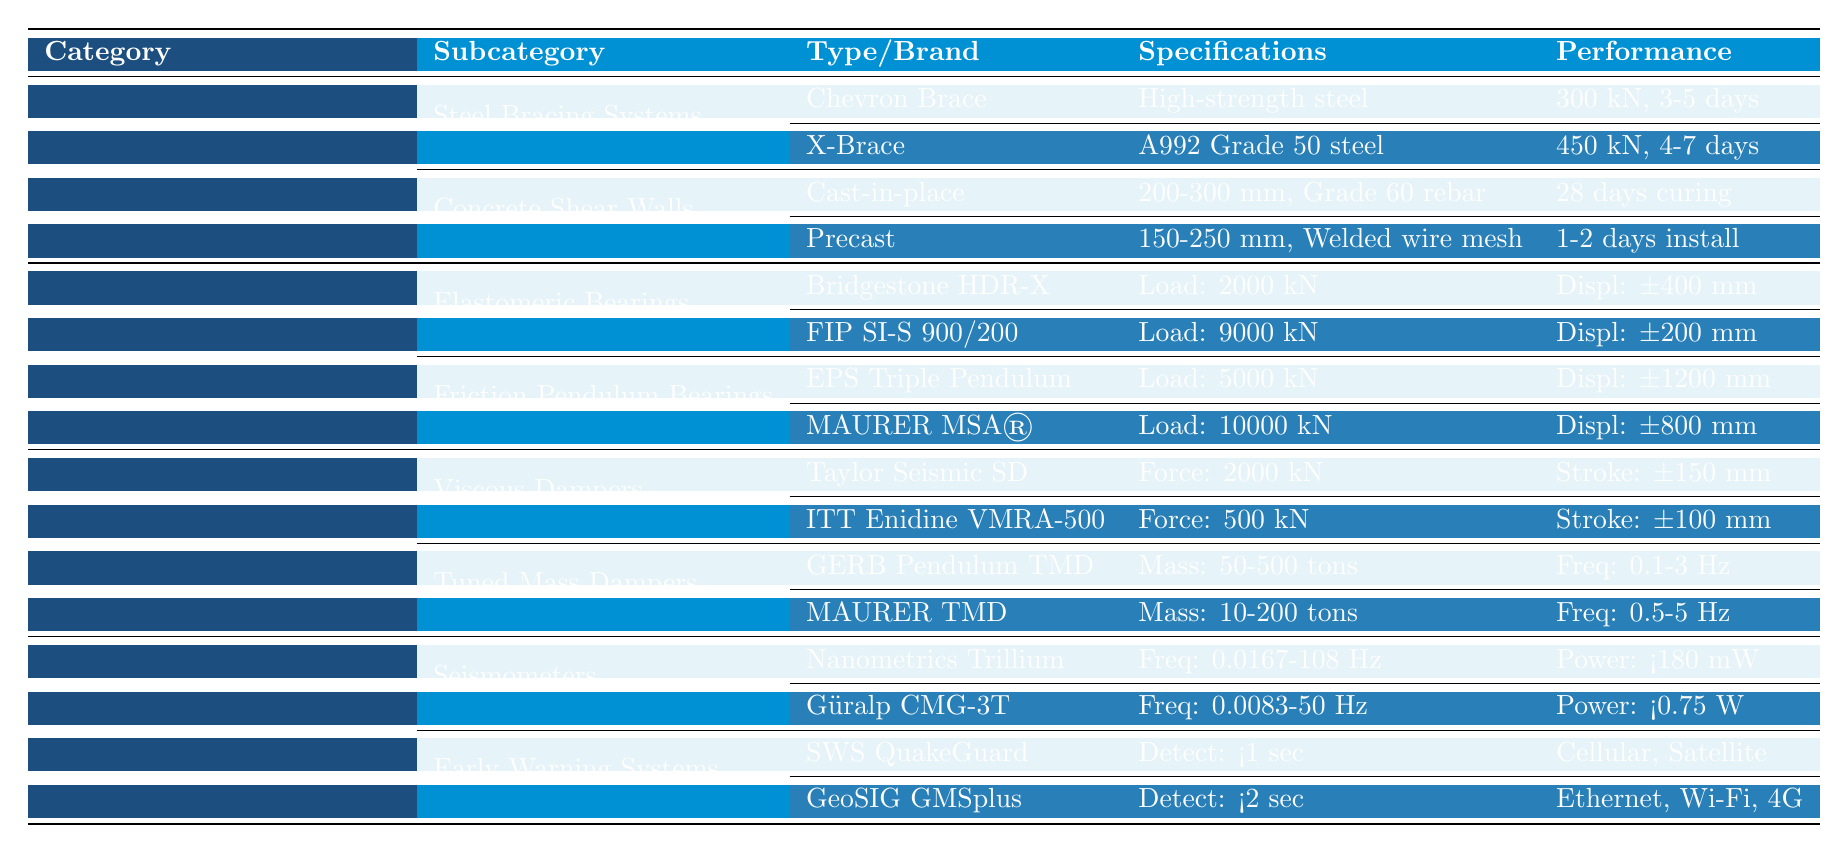What is the load capacity of the X-Brace? The table shows the specifications for the X-Brace under Steel Bracing Systems, indicating a load capacity of 450 kN.
Answer: 450 kN How many installation days are required for the Chevron Brace? The installation time for the Chevron Brace, listed in the Steel Bracing Systems, is between 3 to 5 days.
Answer: 3-5 days Which brand and model of elastomeric bearings has the highest load capacity? Comparing the load capacities listed under Elastomeric Bearings, the FIP SI-S 900/200 has the highest load capacity of 9000 kN, compared to Bridgestone HDR-X with 2000 kN.
Answer: FIP SI-S 900/200 Does the MAURER MSA® Friction Pendulum Bearing have a greater load capacity than the EPS Triple Pendulum? According to the table, the MAURER MSA® has a load capacity of 10000 kN, while the EPS Triple Pendulum has a load capacity of 5000 kN. Therefore, MAURER MSA® does have a greater load capacity.
Answer: Yes What is the frequency range of the GERB Pendulum TMD? The frequency range for the GERB Pendulum TMD, indicated in the Tuned Mass Dampers section, is from 0.1 to 3 Hz.
Answer: 0.1-3 Hz How does the stroke of the Taylor Seismic Damper compare to the stroke of the ITT Enidine VMRA-500? The stroke of the Taylor Seismic Damper is ±150 mm, which is greater than the stroke of the ITT Enidine VMRA-500, which is ±100 mm.
Answer: Greater What is the average detection time for the Early Warning Systems listed? The detection times for SWS QuakeGuard and GeoSIG GMSplus are <1 second and <2 seconds, respectively. Calculating the average: (1 + 2)/2 = 1.5 seconds.
Answer: 1.5 seconds Which has a shorter curing time, Cast-in-place or Precast Concrete Shear Walls? The Cast-in-place wall requires a curing time of 28 days, while the Precast wall installation time is only 1-2 days, indicating Precast is quicker.
Answer: Precast Concrete Shear Walls Can you list the materials used in the Concrete Shear Walls? The table specifies two types of Concrete Shear Walls: the Cast-in-place uses Grade 60 rebar, and the Precast uses Welded wire mesh.
Answer: Grade 60 rebar and Welded wire mesh What is the maximum displacement capability of the MAURER MSA®? The MAURER MSA® Friction Pendulum Bearing has a displacement capability of ±800 mm according to the table.
Answer: ±800 mm 